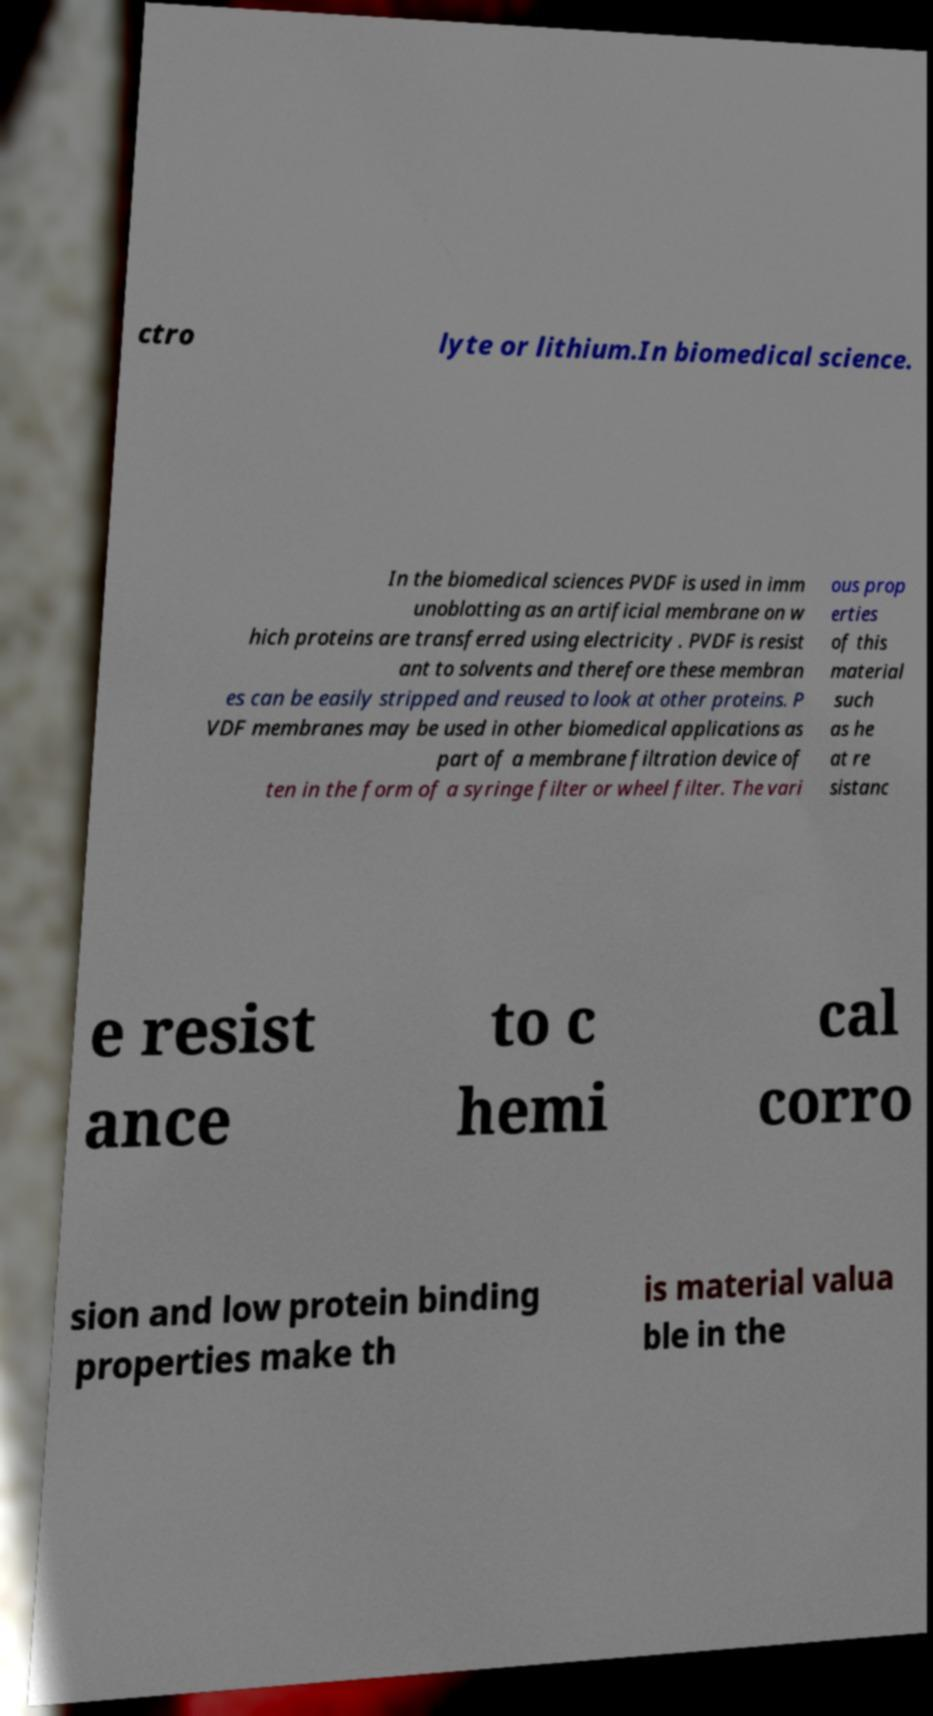For documentation purposes, I need the text within this image transcribed. Could you provide that? ctro lyte or lithium.In biomedical science. In the biomedical sciences PVDF is used in imm unoblotting as an artificial membrane on w hich proteins are transferred using electricity . PVDF is resist ant to solvents and therefore these membran es can be easily stripped and reused to look at other proteins. P VDF membranes may be used in other biomedical applications as part of a membrane filtration device of ten in the form of a syringe filter or wheel filter. The vari ous prop erties of this material such as he at re sistanc e resist ance to c hemi cal corro sion and low protein binding properties make th is material valua ble in the 